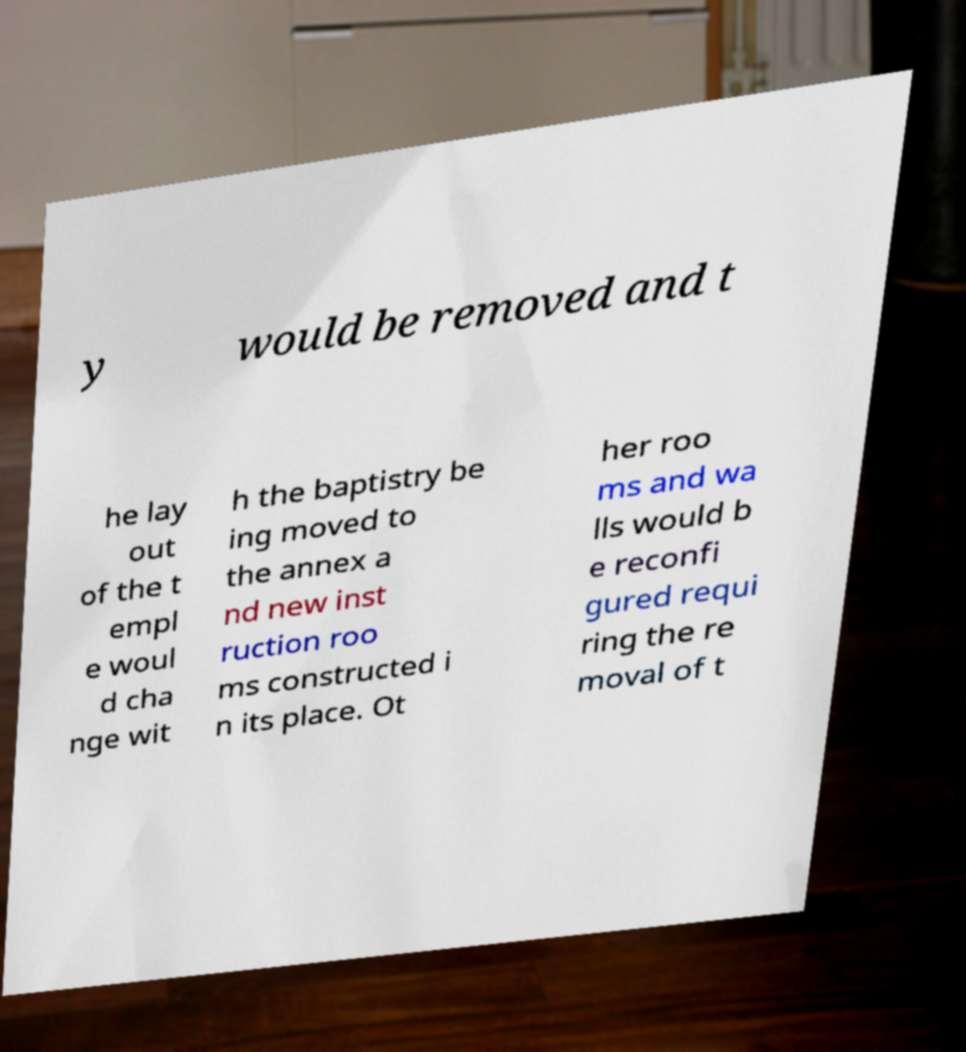Could you extract and type out the text from this image? y would be removed and t he lay out of the t empl e woul d cha nge wit h the baptistry be ing moved to the annex a nd new inst ruction roo ms constructed i n its place. Ot her roo ms and wa lls would b e reconfi gured requi ring the re moval of t 